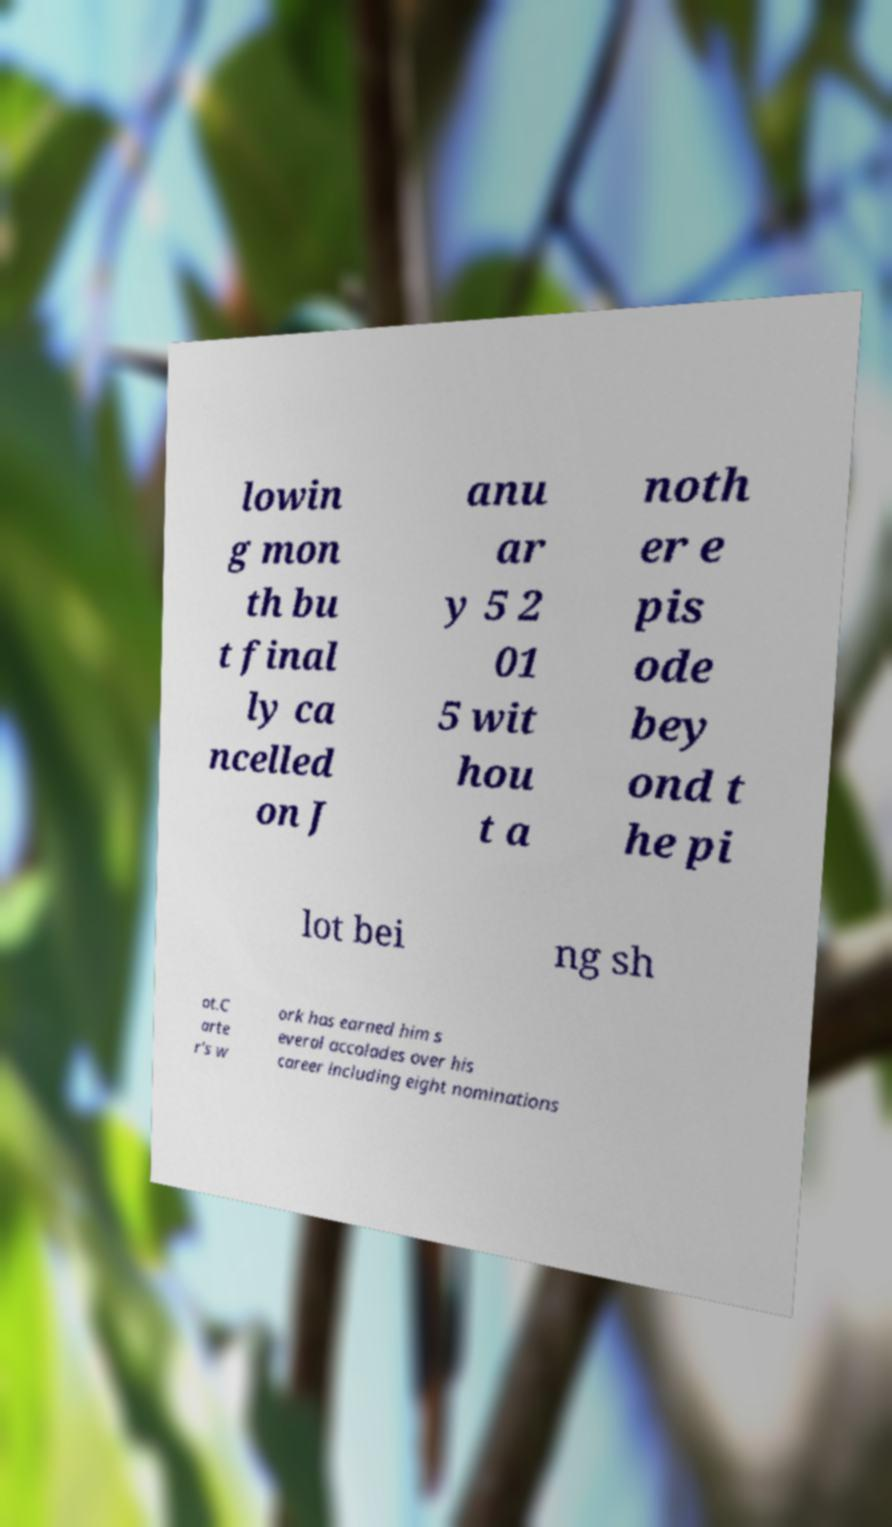Could you assist in decoding the text presented in this image and type it out clearly? lowin g mon th bu t final ly ca ncelled on J anu ar y 5 2 01 5 wit hou t a noth er e pis ode bey ond t he pi lot bei ng sh ot.C arte r's w ork has earned him s everal accolades over his career including eight nominations 